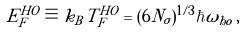Convert formula to latex. <formula><loc_0><loc_0><loc_500><loc_500>E _ { F } ^ { H O } \equiv k _ { B } T _ { F } ^ { H O } = ( 6 N _ { \sigma } ) ^ { 1 / 3 } \hbar { \omega } _ { h o } \, ,</formula> 